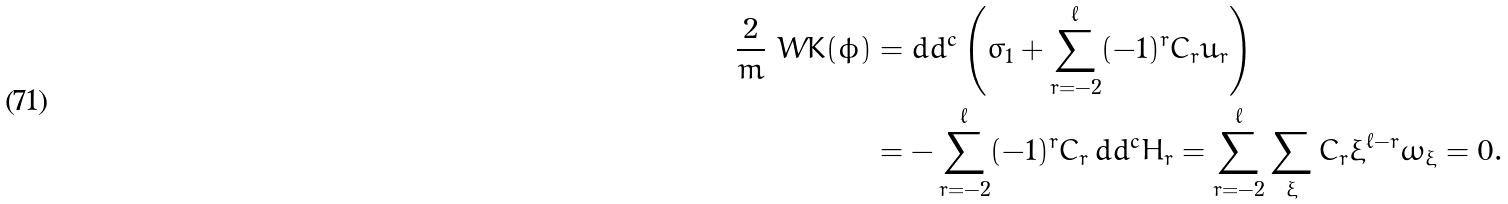Convert formula to latex. <formula><loc_0><loc_0><loc_500><loc_500>\frac { 2 } { m } \ W K ( \phi ) & = d d ^ { c } \left ( \sigma _ { 1 } + \sum _ { r = - 2 } ^ { \ell } ( - 1 ) ^ { r } C _ { r } u _ { r } \right ) \\ & = - \sum _ { r = - 2 } ^ { \ell } ( - 1 ) ^ { r } C _ { r } \, d d ^ { c } H _ { r } = \sum _ { r = - 2 } ^ { \ell } \sum _ { \xi } C _ { r } \xi ^ { \ell - r } \omega _ { \xi } = 0 .</formula> 